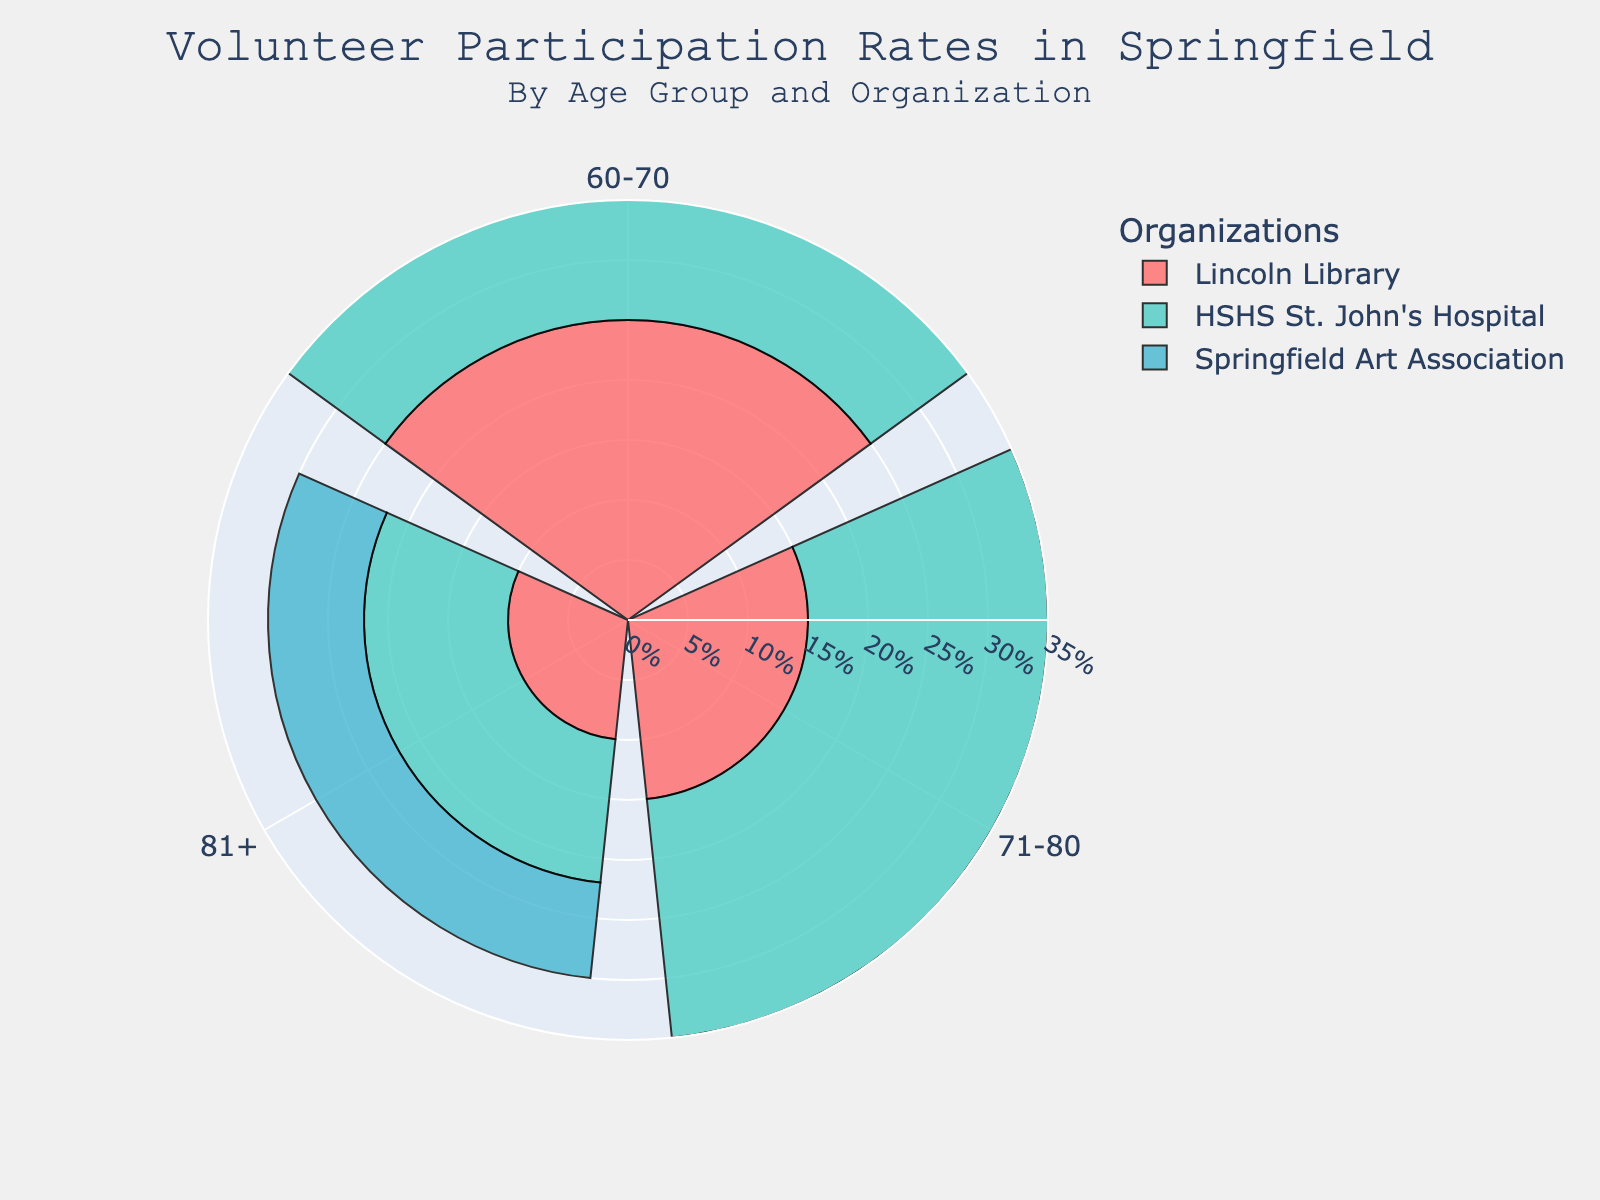What is the title of the figure? The title is usually located at the top of the figure, providing a summary of what the chart represents. In this case, it gives information on volunteer participation rates in Springfield by age group and organization.
Answer: Volunteer Participation Rates in Springfield How many age groups are represented in the chart? Count the number of unique age groups shown in the chart, which are represented by different segments or sections.
Answer: 3 Which organization has the highest volunteer rate for the age group 60-70? Find the maximum volunteer rate in the 60-70 age group by looking at the lengths of the bars for this age group and identify the organization associated with the longest bar.
Answer: HSHS St. John's Hospital What is the difference in volunteer rates between Lincoln Library and Springfield Art Association for the age group 71-80? Look at the bar lengths for Lincoln Library and Springfield Art Association in the 71-80 age group, subtract the volunteer rate of Springfield Art Association from that of Lincoln Library.
Answer: -3 Which age group has the lowest overall volunteer participation rate? Compare the sum of volunteer rates across all organizations for each age group and identify the group with the lowest total.
Answer: 81+ What is the total volunteer rate for HSHS St. John's Hospital across all age groups? Add up the volunteer rates for HSHS St. John's Hospital for each of the represented age groups.
Answer: 62% For which age group does Springfield Art Association have the highest volunteer rate? Examine the volunteer rates of Springfield Art Association for each age group and identify the age group with the highest rate.
Answer: 60-70 How does the volunteer rate for Lincoln Library change across the age groups? Check the bars representing Lincoln Library in each age group and observe the trend in volunteer rates.
Answer: Decreases Which organization shows the smallest change in volunteer rates across different age groups? Evaluate the differences in volunteer rates across age groups for each organization and identify the organization with the smallest variation.
Answer: Springfield Art Association How does the volunteer participation rate for the age group 81+ compare to that of 60-70 within HSHS St. John's Hospital? Subtract the volunteer rate for the 81+ age group from that of the 60-70 age group within HSHS St. John's Hospital.
Answer: -18 